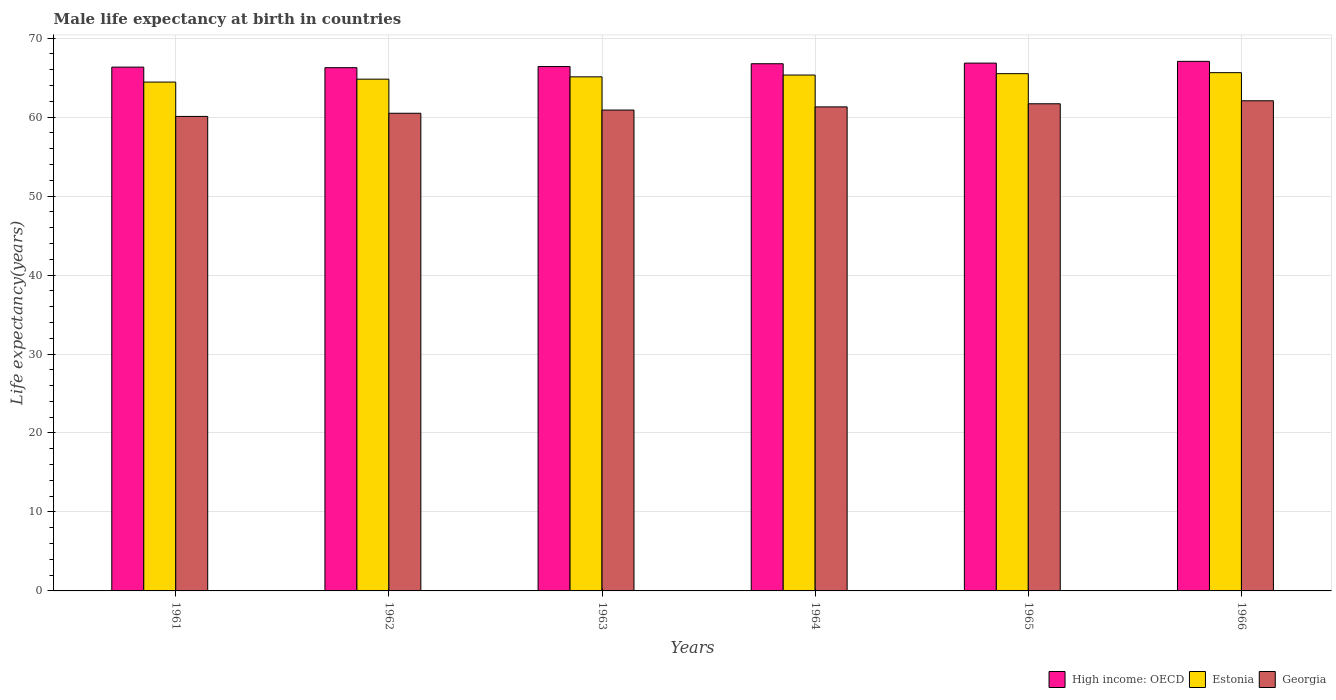How many different coloured bars are there?
Give a very brief answer. 3. Are the number of bars per tick equal to the number of legend labels?
Offer a terse response. Yes. How many bars are there on the 2nd tick from the right?
Provide a succinct answer. 3. What is the label of the 3rd group of bars from the left?
Provide a succinct answer. 1963. What is the male life expectancy at birth in High income: OECD in 1966?
Your response must be concise. 67.06. Across all years, what is the maximum male life expectancy at birth in High income: OECD?
Provide a succinct answer. 67.06. Across all years, what is the minimum male life expectancy at birth in High income: OECD?
Ensure brevity in your answer.  66.26. In which year was the male life expectancy at birth in Estonia maximum?
Provide a succinct answer. 1966. What is the total male life expectancy at birth in Georgia in the graph?
Provide a short and direct response. 366.52. What is the difference between the male life expectancy at birth in Estonia in 1961 and that in 1963?
Provide a succinct answer. -0.66. What is the difference between the male life expectancy at birth in High income: OECD in 1965 and the male life expectancy at birth in Estonia in 1962?
Your answer should be compact. 2.03. What is the average male life expectancy at birth in Georgia per year?
Your answer should be compact. 61.09. In the year 1961, what is the difference between the male life expectancy at birth in Georgia and male life expectancy at birth in Estonia?
Keep it short and to the point. -4.35. In how many years, is the male life expectancy at birth in Estonia greater than 30 years?
Offer a terse response. 6. What is the ratio of the male life expectancy at birth in Estonia in 1962 to that in 1965?
Ensure brevity in your answer.  0.99. Is the male life expectancy at birth in High income: OECD in 1963 less than that in 1965?
Keep it short and to the point. Yes. What is the difference between the highest and the second highest male life expectancy at birth in High income: OECD?
Offer a terse response. 0.22. What is the difference between the highest and the lowest male life expectancy at birth in Estonia?
Your answer should be compact. 1.19. In how many years, is the male life expectancy at birth in High income: OECD greater than the average male life expectancy at birth in High income: OECD taken over all years?
Your response must be concise. 3. What does the 2nd bar from the left in 1961 represents?
Your answer should be very brief. Estonia. What does the 3rd bar from the right in 1966 represents?
Provide a short and direct response. High income: OECD. Is it the case that in every year, the sum of the male life expectancy at birth in Estonia and male life expectancy at birth in Georgia is greater than the male life expectancy at birth in High income: OECD?
Make the answer very short. Yes. Are all the bars in the graph horizontal?
Offer a terse response. No. How many years are there in the graph?
Keep it short and to the point. 6. What is the title of the graph?
Offer a very short reply. Male life expectancy at birth in countries. Does "Latin America(developing only)" appear as one of the legend labels in the graph?
Keep it short and to the point. No. What is the label or title of the Y-axis?
Provide a succinct answer. Life expectancy(years). What is the Life expectancy(years) in High income: OECD in 1961?
Provide a succinct answer. 66.33. What is the Life expectancy(years) of Estonia in 1961?
Offer a terse response. 64.44. What is the Life expectancy(years) of Georgia in 1961?
Offer a very short reply. 60.09. What is the Life expectancy(years) of High income: OECD in 1962?
Make the answer very short. 66.26. What is the Life expectancy(years) of Estonia in 1962?
Offer a terse response. 64.8. What is the Life expectancy(years) in Georgia in 1962?
Offer a very short reply. 60.49. What is the Life expectancy(years) of High income: OECD in 1963?
Make the answer very short. 66.4. What is the Life expectancy(years) in Estonia in 1963?
Offer a terse response. 65.1. What is the Life expectancy(years) in Georgia in 1963?
Provide a short and direct response. 60.89. What is the Life expectancy(years) in High income: OECD in 1964?
Your response must be concise. 66.76. What is the Life expectancy(years) of Estonia in 1964?
Provide a short and direct response. 65.33. What is the Life expectancy(years) in Georgia in 1964?
Give a very brief answer. 61.29. What is the Life expectancy(years) of High income: OECD in 1965?
Offer a very short reply. 66.84. What is the Life expectancy(years) of Estonia in 1965?
Give a very brief answer. 65.5. What is the Life expectancy(years) of Georgia in 1965?
Give a very brief answer. 61.69. What is the Life expectancy(years) in High income: OECD in 1966?
Offer a terse response. 67.06. What is the Life expectancy(years) of Estonia in 1966?
Offer a terse response. 65.63. What is the Life expectancy(years) in Georgia in 1966?
Offer a terse response. 62.07. Across all years, what is the maximum Life expectancy(years) in High income: OECD?
Your response must be concise. 67.06. Across all years, what is the maximum Life expectancy(years) of Estonia?
Give a very brief answer. 65.63. Across all years, what is the maximum Life expectancy(years) of Georgia?
Your response must be concise. 62.07. Across all years, what is the minimum Life expectancy(years) of High income: OECD?
Provide a short and direct response. 66.26. Across all years, what is the minimum Life expectancy(years) of Estonia?
Make the answer very short. 64.44. Across all years, what is the minimum Life expectancy(years) in Georgia?
Provide a succinct answer. 60.09. What is the total Life expectancy(years) in High income: OECD in the graph?
Offer a terse response. 399.65. What is the total Life expectancy(years) in Estonia in the graph?
Your answer should be very brief. 390.8. What is the total Life expectancy(years) in Georgia in the graph?
Your response must be concise. 366.52. What is the difference between the Life expectancy(years) of High income: OECD in 1961 and that in 1962?
Ensure brevity in your answer.  0.07. What is the difference between the Life expectancy(years) of Estonia in 1961 and that in 1962?
Keep it short and to the point. -0.37. What is the difference between the Life expectancy(years) of Georgia in 1961 and that in 1962?
Offer a very short reply. -0.4. What is the difference between the Life expectancy(years) in High income: OECD in 1961 and that in 1963?
Your answer should be very brief. -0.07. What is the difference between the Life expectancy(years) of Estonia in 1961 and that in 1963?
Give a very brief answer. -0.66. What is the difference between the Life expectancy(years) in Georgia in 1961 and that in 1963?
Give a very brief answer. -0.81. What is the difference between the Life expectancy(years) in High income: OECD in 1961 and that in 1964?
Ensure brevity in your answer.  -0.43. What is the difference between the Life expectancy(years) in Estonia in 1961 and that in 1964?
Give a very brief answer. -0.89. What is the difference between the Life expectancy(years) in Georgia in 1961 and that in 1964?
Make the answer very short. -1.21. What is the difference between the Life expectancy(years) in High income: OECD in 1961 and that in 1965?
Offer a terse response. -0.51. What is the difference between the Life expectancy(years) of Estonia in 1961 and that in 1965?
Your response must be concise. -1.06. What is the difference between the Life expectancy(years) in Georgia in 1961 and that in 1965?
Your response must be concise. -1.6. What is the difference between the Life expectancy(years) in High income: OECD in 1961 and that in 1966?
Your response must be concise. -0.73. What is the difference between the Life expectancy(years) in Estonia in 1961 and that in 1966?
Offer a very short reply. -1.19. What is the difference between the Life expectancy(years) in Georgia in 1961 and that in 1966?
Offer a very short reply. -1.98. What is the difference between the Life expectancy(years) in High income: OECD in 1962 and that in 1963?
Provide a succinct answer. -0.14. What is the difference between the Life expectancy(years) of Estonia in 1962 and that in 1963?
Keep it short and to the point. -0.29. What is the difference between the Life expectancy(years) in Georgia in 1962 and that in 1963?
Your answer should be very brief. -0.4. What is the difference between the Life expectancy(years) of High income: OECD in 1962 and that in 1964?
Offer a terse response. -0.5. What is the difference between the Life expectancy(years) in Estonia in 1962 and that in 1964?
Offer a terse response. -0.52. What is the difference between the Life expectancy(years) in Georgia in 1962 and that in 1964?
Your answer should be compact. -0.81. What is the difference between the Life expectancy(years) in High income: OECD in 1962 and that in 1965?
Provide a succinct answer. -0.58. What is the difference between the Life expectancy(years) in Estonia in 1962 and that in 1965?
Provide a succinct answer. -0.7. What is the difference between the Life expectancy(years) in High income: OECD in 1962 and that in 1966?
Your response must be concise. -0.8. What is the difference between the Life expectancy(years) of Estonia in 1962 and that in 1966?
Provide a succinct answer. -0.82. What is the difference between the Life expectancy(years) of Georgia in 1962 and that in 1966?
Offer a terse response. -1.58. What is the difference between the Life expectancy(years) in High income: OECD in 1963 and that in 1964?
Offer a very short reply. -0.36. What is the difference between the Life expectancy(years) of Estonia in 1963 and that in 1964?
Make the answer very short. -0.23. What is the difference between the Life expectancy(years) of Georgia in 1963 and that in 1964?
Provide a succinct answer. -0.4. What is the difference between the Life expectancy(years) of High income: OECD in 1963 and that in 1965?
Ensure brevity in your answer.  -0.44. What is the difference between the Life expectancy(years) of Estonia in 1963 and that in 1965?
Give a very brief answer. -0.41. What is the difference between the Life expectancy(years) of Georgia in 1963 and that in 1965?
Keep it short and to the point. -0.8. What is the difference between the Life expectancy(years) in High income: OECD in 1963 and that in 1966?
Provide a short and direct response. -0.66. What is the difference between the Life expectancy(years) of Estonia in 1963 and that in 1966?
Provide a short and direct response. -0.53. What is the difference between the Life expectancy(years) in Georgia in 1963 and that in 1966?
Your answer should be compact. -1.18. What is the difference between the Life expectancy(years) of High income: OECD in 1964 and that in 1965?
Ensure brevity in your answer.  -0.08. What is the difference between the Life expectancy(years) in Estonia in 1964 and that in 1965?
Offer a terse response. -0.17. What is the difference between the Life expectancy(years) of Georgia in 1964 and that in 1965?
Your answer should be very brief. -0.39. What is the difference between the Life expectancy(years) of High income: OECD in 1964 and that in 1966?
Keep it short and to the point. -0.3. What is the difference between the Life expectancy(years) of Estonia in 1964 and that in 1966?
Offer a terse response. -0.3. What is the difference between the Life expectancy(years) in Georgia in 1964 and that in 1966?
Give a very brief answer. -0.78. What is the difference between the Life expectancy(years) in High income: OECD in 1965 and that in 1966?
Your answer should be very brief. -0.22. What is the difference between the Life expectancy(years) of Estonia in 1965 and that in 1966?
Your response must be concise. -0.13. What is the difference between the Life expectancy(years) of Georgia in 1965 and that in 1966?
Your answer should be very brief. -0.38. What is the difference between the Life expectancy(years) of High income: OECD in 1961 and the Life expectancy(years) of Estonia in 1962?
Make the answer very short. 1.53. What is the difference between the Life expectancy(years) of High income: OECD in 1961 and the Life expectancy(years) of Georgia in 1962?
Provide a short and direct response. 5.84. What is the difference between the Life expectancy(years) in Estonia in 1961 and the Life expectancy(years) in Georgia in 1962?
Offer a terse response. 3.95. What is the difference between the Life expectancy(years) in High income: OECD in 1961 and the Life expectancy(years) in Estonia in 1963?
Ensure brevity in your answer.  1.23. What is the difference between the Life expectancy(years) of High income: OECD in 1961 and the Life expectancy(years) of Georgia in 1963?
Provide a succinct answer. 5.44. What is the difference between the Life expectancy(years) in Estonia in 1961 and the Life expectancy(years) in Georgia in 1963?
Your answer should be very brief. 3.54. What is the difference between the Life expectancy(years) in High income: OECD in 1961 and the Life expectancy(years) in Georgia in 1964?
Keep it short and to the point. 5.04. What is the difference between the Life expectancy(years) in Estonia in 1961 and the Life expectancy(years) in Georgia in 1964?
Keep it short and to the point. 3.14. What is the difference between the Life expectancy(years) of High income: OECD in 1961 and the Life expectancy(years) of Estonia in 1965?
Provide a succinct answer. 0.83. What is the difference between the Life expectancy(years) of High income: OECD in 1961 and the Life expectancy(years) of Georgia in 1965?
Keep it short and to the point. 4.64. What is the difference between the Life expectancy(years) of Estonia in 1961 and the Life expectancy(years) of Georgia in 1965?
Offer a terse response. 2.75. What is the difference between the Life expectancy(years) of High income: OECD in 1961 and the Life expectancy(years) of Estonia in 1966?
Your answer should be compact. 0.7. What is the difference between the Life expectancy(years) in High income: OECD in 1961 and the Life expectancy(years) in Georgia in 1966?
Offer a terse response. 4.26. What is the difference between the Life expectancy(years) of Estonia in 1961 and the Life expectancy(years) of Georgia in 1966?
Ensure brevity in your answer.  2.37. What is the difference between the Life expectancy(years) in High income: OECD in 1962 and the Life expectancy(years) in Estonia in 1963?
Ensure brevity in your answer.  1.16. What is the difference between the Life expectancy(years) in High income: OECD in 1962 and the Life expectancy(years) in Georgia in 1963?
Offer a very short reply. 5.37. What is the difference between the Life expectancy(years) in Estonia in 1962 and the Life expectancy(years) in Georgia in 1963?
Your response must be concise. 3.91. What is the difference between the Life expectancy(years) of High income: OECD in 1962 and the Life expectancy(years) of Estonia in 1964?
Your response must be concise. 0.93. What is the difference between the Life expectancy(years) in High income: OECD in 1962 and the Life expectancy(years) in Georgia in 1964?
Ensure brevity in your answer.  4.97. What is the difference between the Life expectancy(years) of Estonia in 1962 and the Life expectancy(years) of Georgia in 1964?
Ensure brevity in your answer.  3.51. What is the difference between the Life expectancy(years) in High income: OECD in 1962 and the Life expectancy(years) in Estonia in 1965?
Provide a succinct answer. 0.76. What is the difference between the Life expectancy(years) in High income: OECD in 1962 and the Life expectancy(years) in Georgia in 1965?
Provide a succinct answer. 4.57. What is the difference between the Life expectancy(years) in Estonia in 1962 and the Life expectancy(years) in Georgia in 1965?
Your answer should be very brief. 3.12. What is the difference between the Life expectancy(years) in High income: OECD in 1962 and the Life expectancy(years) in Estonia in 1966?
Your response must be concise. 0.63. What is the difference between the Life expectancy(years) of High income: OECD in 1962 and the Life expectancy(years) of Georgia in 1966?
Offer a very short reply. 4.19. What is the difference between the Life expectancy(years) in Estonia in 1962 and the Life expectancy(years) in Georgia in 1966?
Offer a terse response. 2.73. What is the difference between the Life expectancy(years) of High income: OECD in 1963 and the Life expectancy(years) of Estonia in 1964?
Offer a very short reply. 1.07. What is the difference between the Life expectancy(years) in High income: OECD in 1963 and the Life expectancy(years) in Georgia in 1964?
Offer a very short reply. 5.11. What is the difference between the Life expectancy(years) in Estonia in 1963 and the Life expectancy(years) in Georgia in 1964?
Keep it short and to the point. 3.8. What is the difference between the Life expectancy(years) of High income: OECD in 1963 and the Life expectancy(years) of Estonia in 1965?
Your answer should be very brief. 0.9. What is the difference between the Life expectancy(years) in High income: OECD in 1963 and the Life expectancy(years) in Georgia in 1965?
Give a very brief answer. 4.71. What is the difference between the Life expectancy(years) of Estonia in 1963 and the Life expectancy(years) of Georgia in 1965?
Your response must be concise. 3.41. What is the difference between the Life expectancy(years) in High income: OECD in 1963 and the Life expectancy(years) in Estonia in 1966?
Provide a succinct answer. 0.77. What is the difference between the Life expectancy(years) of High income: OECD in 1963 and the Life expectancy(years) of Georgia in 1966?
Give a very brief answer. 4.33. What is the difference between the Life expectancy(years) in Estonia in 1963 and the Life expectancy(years) in Georgia in 1966?
Your response must be concise. 3.03. What is the difference between the Life expectancy(years) in High income: OECD in 1964 and the Life expectancy(years) in Estonia in 1965?
Offer a terse response. 1.26. What is the difference between the Life expectancy(years) in High income: OECD in 1964 and the Life expectancy(years) in Georgia in 1965?
Give a very brief answer. 5.07. What is the difference between the Life expectancy(years) in Estonia in 1964 and the Life expectancy(years) in Georgia in 1965?
Provide a succinct answer. 3.64. What is the difference between the Life expectancy(years) in High income: OECD in 1964 and the Life expectancy(years) in Estonia in 1966?
Offer a terse response. 1.13. What is the difference between the Life expectancy(years) of High income: OECD in 1964 and the Life expectancy(years) of Georgia in 1966?
Offer a very short reply. 4.69. What is the difference between the Life expectancy(years) of Estonia in 1964 and the Life expectancy(years) of Georgia in 1966?
Make the answer very short. 3.26. What is the difference between the Life expectancy(years) in High income: OECD in 1965 and the Life expectancy(years) in Estonia in 1966?
Your answer should be compact. 1.21. What is the difference between the Life expectancy(years) of High income: OECD in 1965 and the Life expectancy(years) of Georgia in 1966?
Your answer should be very brief. 4.77. What is the difference between the Life expectancy(years) of Estonia in 1965 and the Life expectancy(years) of Georgia in 1966?
Keep it short and to the point. 3.43. What is the average Life expectancy(years) in High income: OECD per year?
Provide a succinct answer. 66.61. What is the average Life expectancy(years) in Estonia per year?
Offer a very short reply. 65.13. What is the average Life expectancy(years) of Georgia per year?
Ensure brevity in your answer.  61.09. In the year 1961, what is the difference between the Life expectancy(years) of High income: OECD and Life expectancy(years) of Estonia?
Keep it short and to the point. 1.89. In the year 1961, what is the difference between the Life expectancy(years) of High income: OECD and Life expectancy(years) of Georgia?
Your response must be concise. 6.24. In the year 1961, what is the difference between the Life expectancy(years) in Estonia and Life expectancy(years) in Georgia?
Your response must be concise. 4.35. In the year 1962, what is the difference between the Life expectancy(years) of High income: OECD and Life expectancy(years) of Estonia?
Offer a terse response. 1.46. In the year 1962, what is the difference between the Life expectancy(years) in High income: OECD and Life expectancy(years) in Georgia?
Give a very brief answer. 5.77. In the year 1962, what is the difference between the Life expectancy(years) of Estonia and Life expectancy(years) of Georgia?
Your answer should be very brief. 4.32. In the year 1963, what is the difference between the Life expectancy(years) of High income: OECD and Life expectancy(years) of Estonia?
Your response must be concise. 1.3. In the year 1963, what is the difference between the Life expectancy(years) in High income: OECD and Life expectancy(years) in Georgia?
Make the answer very short. 5.51. In the year 1963, what is the difference between the Life expectancy(years) of Estonia and Life expectancy(years) of Georgia?
Your response must be concise. 4.21. In the year 1964, what is the difference between the Life expectancy(years) in High income: OECD and Life expectancy(years) in Estonia?
Offer a very short reply. 1.43. In the year 1964, what is the difference between the Life expectancy(years) in High income: OECD and Life expectancy(years) in Georgia?
Provide a short and direct response. 5.46. In the year 1964, what is the difference between the Life expectancy(years) in Estonia and Life expectancy(years) in Georgia?
Make the answer very short. 4.03. In the year 1965, what is the difference between the Life expectancy(years) of High income: OECD and Life expectancy(years) of Estonia?
Ensure brevity in your answer.  1.34. In the year 1965, what is the difference between the Life expectancy(years) of High income: OECD and Life expectancy(years) of Georgia?
Your answer should be compact. 5.15. In the year 1965, what is the difference between the Life expectancy(years) of Estonia and Life expectancy(years) of Georgia?
Offer a terse response. 3.81. In the year 1966, what is the difference between the Life expectancy(years) of High income: OECD and Life expectancy(years) of Estonia?
Provide a short and direct response. 1.43. In the year 1966, what is the difference between the Life expectancy(years) of High income: OECD and Life expectancy(years) of Georgia?
Your answer should be very brief. 4.99. In the year 1966, what is the difference between the Life expectancy(years) in Estonia and Life expectancy(years) in Georgia?
Your answer should be compact. 3.56. What is the ratio of the Life expectancy(years) in Estonia in 1961 to that in 1964?
Give a very brief answer. 0.99. What is the ratio of the Life expectancy(years) in Georgia in 1961 to that in 1964?
Provide a succinct answer. 0.98. What is the ratio of the Life expectancy(years) of High income: OECD in 1961 to that in 1965?
Your answer should be compact. 0.99. What is the ratio of the Life expectancy(years) in Estonia in 1961 to that in 1965?
Provide a short and direct response. 0.98. What is the ratio of the Life expectancy(years) in Estonia in 1961 to that in 1966?
Provide a succinct answer. 0.98. What is the ratio of the Life expectancy(years) of Georgia in 1961 to that in 1966?
Offer a very short reply. 0.97. What is the ratio of the Life expectancy(years) in Georgia in 1962 to that in 1963?
Your response must be concise. 0.99. What is the ratio of the Life expectancy(years) in High income: OECD in 1962 to that in 1964?
Offer a terse response. 0.99. What is the ratio of the Life expectancy(years) of Georgia in 1962 to that in 1964?
Ensure brevity in your answer.  0.99. What is the ratio of the Life expectancy(years) in Estonia in 1962 to that in 1965?
Provide a short and direct response. 0.99. What is the ratio of the Life expectancy(years) of Georgia in 1962 to that in 1965?
Provide a short and direct response. 0.98. What is the ratio of the Life expectancy(years) in High income: OECD in 1962 to that in 1966?
Make the answer very short. 0.99. What is the ratio of the Life expectancy(years) of Estonia in 1962 to that in 1966?
Ensure brevity in your answer.  0.99. What is the ratio of the Life expectancy(years) in Georgia in 1962 to that in 1966?
Ensure brevity in your answer.  0.97. What is the ratio of the Life expectancy(years) of High income: OECD in 1963 to that in 1964?
Keep it short and to the point. 0.99. What is the ratio of the Life expectancy(years) in Estonia in 1963 to that in 1964?
Provide a succinct answer. 1. What is the ratio of the Life expectancy(years) of Georgia in 1963 to that in 1964?
Make the answer very short. 0.99. What is the ratio of the Life expectancy(years) in Georgia in 1963 to that in 1965?
Your answer should be compact. 0.99. What is the ratio of the Life expectancy(years) of High income: OECD in 1963 to that in 1966?
Make the answer very short. 0.99. What is the ratio of the Life expectancy(years) of Georgia in 1963 to that in 1966?
Your response must be concise. 0.98. What is the ratio of the Life expectancy(years) in Estonia in 1964 to that in 1965?
Keep it short and to the point. 1. What is the ratio of the Life expectancy(years) in Georgia in 1964 to that in 1965?
Make the answer very short. 0.99. What is the ratio of the Life expectancy(years) of Estonia in 1964 to that in 1966?
Provide a succinct answer. 1. What is the ratio of the Life expectancy(years) in Georgia in 1964 to that in 1966?
Offer a very short reply. 0.99. What is the ratio of the Life expectancy(years) of High income: OECD in 1965 to that in 1966?
Provide a succinct answer. 1. What is the ratio of the Life expectancy(years) in Estonia in 1965 to that in 1966?
Offer a very short reply. 1. What is the difference between the highest and the second highest Life expectancy(years) in High income: OECD?
Keep it short and to the point. 0.22. What is the difference between the highest and the second highest Life expectancy(years) in Estonia?
Make the answer very short. 0.13. What is the difference between the highest and the second highest Life expectancy(years) in Georgia?
Provide a succinct answer. 0.38. What is the difference between the highest and the lowest Life expectancy(years) in High income: OECD?
Give a very brief answer. 0.8. What is the difference between the highest and the lowest Life expectancy(years) of Estonia?
Your answer should be compact. 1.19. What is the difference between the highest and the lowest Life expectancy(years) in Georgia?
Ensure brevity in your answer.  1.98. 